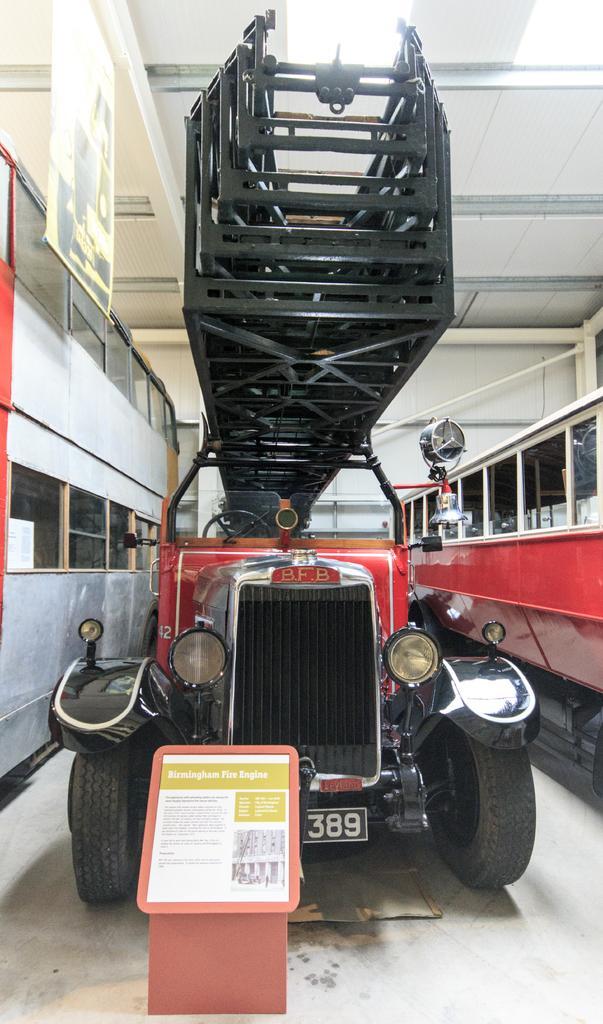In one or two sentences, can you explain what this image depicts? There is a vehicle in the foreground and a poster at the bottom side, it seems like glass windows on both the sides, there is a poster and a roof at the top side. 